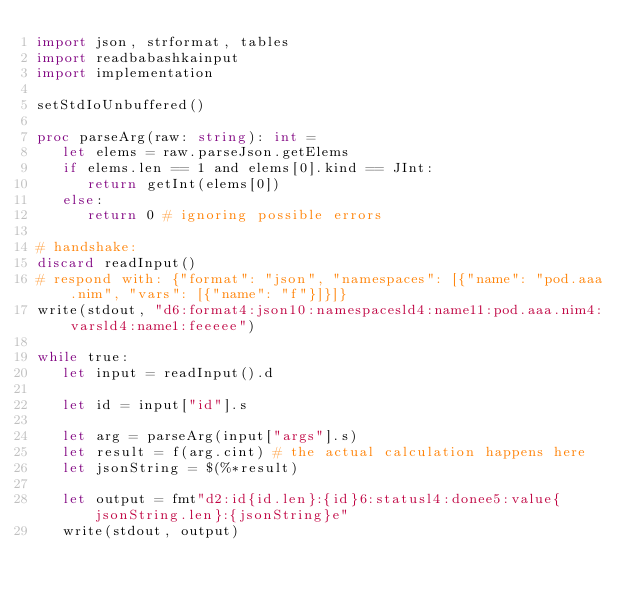Convert code to text. <code><loc_0><loc_0><loc_500><loc_500><_Nim_>import json, strformat, tables
import readbabashkainput
import implementation

setStdIoUnbuffered()

proc parseArg(raw: string): int =
   let elems = raw.parseJson.getElems
   if elems.len == 1 and elems[0].kind == JInt:
      return getInt(elems[0])
   else:
      return 0 # ignoring possible errors

# handshake:
discard readInput()
# respond with: {"format": "json", "namespaces": [{"name": "pod.aaa.nim", "vars": [{"name": "f"}]}]}
write(stdout, "d6:format4:json10:namespacesld4:name11:pod.aaa.nim4:varsld4:name1:feeeee")

while true:
   let input = readInput().d
   
   let id = input["id"].s

   let arg = parseArg(input["args"].s)
   let result = f(arg.cint) # the actual calculation happens here
   let jsonString = $(%*result)
   
   let output = fmt"d2:id{id.len}:{id}6:statusl4:donee5:value{jsonString.len}:{jsonString}e"
   write(stdout, output)
</code> 